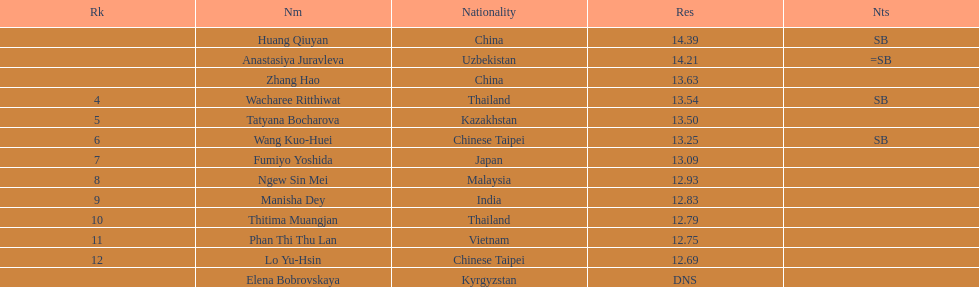In which country was the top spot achieved? China. 